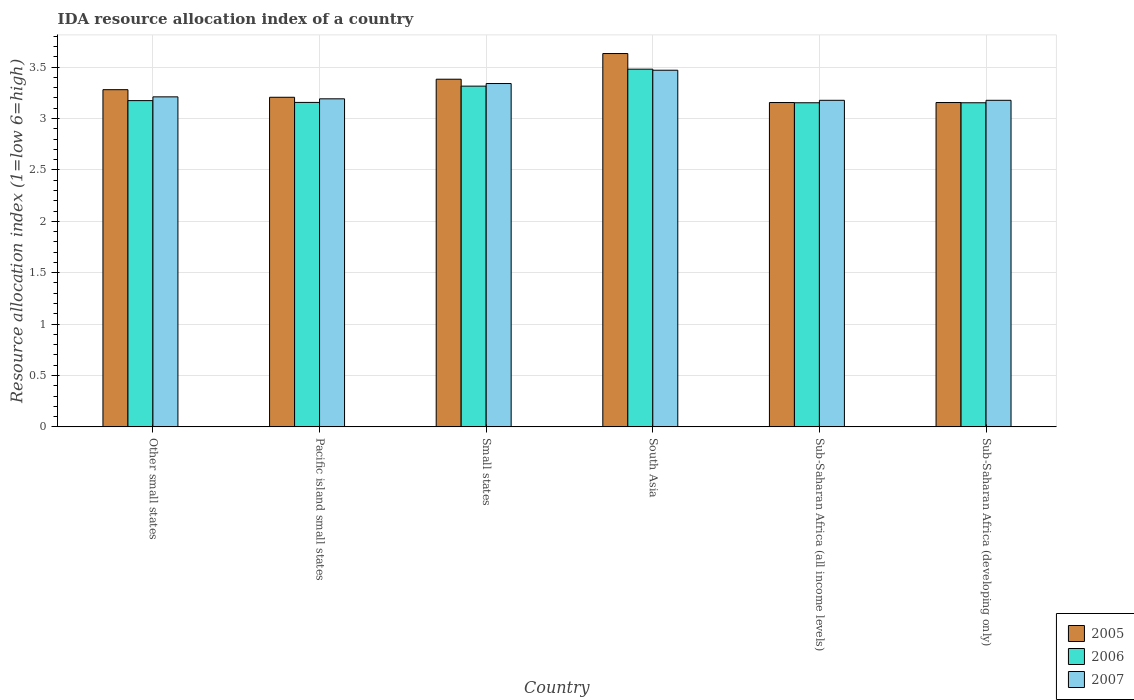In how many cases, is the number of bars for a given country not equal to the number of legend labels?
Offer a very short reply. 0. What is the IDA resource allocation index in 2005 in Pacific island small states?
Provide a succinct answer. 3.21. Across all countries, what is the maximum IDA resource allocation index in 2005?
Give a very brief answer. 3.63. Across all countries, what is the minimum IDA resource allocation index in 2007?
Give a very brief answer. 3.18. In which country was the IDA resource allocation index in 2006 maximum?
Give a very brief answer. South Asia. In which country was the IDA resource allocation index in 2007 minimum?
Offer a terse response. Sub-Saharan Africa (all income levels). What is the total IDA resource allocation index in 2006 in the graph?
Ensure brevity in your answer.  19.43. What is the difference between the IDA resource allocation index in 2006 in Small states and that in South Asia?
Your answer should be very brief. -0.17. What is the difference between the IDA resource allocation index in 2007 in Pacific island small states and the IDA resource allocation index in 2005 in South Asia?
Your answer should be very brief. -0.44. What is the average IDA resource allocation index in 2006 per country?
Provide a short and direct response. 3.24. What is the difference between the IDA resource allocation index of/in 2005 and IDA resource allocation index of/in 2007 in Small states?
Provide a short and direct response. 0.04. What is the ratio of the IDA resource allocation index in 2005 in Small states to that in Sub-Saharan Africa (all income levels)?
Give a very brief answer. 1.07. Is the difference between the IDA resource allocation index in 2005 in Small states and South Asia greater than the difference between the IDA resource allocation index in 2007 in Small states and South Asia?
Your response must be concise. No. What is the difference between the highest and the second highest IDA resource allocation index in 2005?
Make the answer very short. -0.25. What is the difference between the highest and the lowest IDA resource allocation index in 2007?
Offer a very short reply. 0.29. In how many countries, is the IDA resource allocation index in 2006 greater than the average IDA resource allocation index in 2006 taken over all countries?
Offer a terse response. 2. Is the sum of the IDA resource allocation index in 2007 in Small states and Sub-Saharan Africa (developing only) greater than the maximum IDA resource allocation index in 2005 across all countries?
Offer a terse response. Yes. What does the 1st bar from the left in Small states represents?
Your answer should be very brief. 2005. What does the 3rd bar from the right in Small states represents?
Make the answer very short. 2005. Is it the case that in every country, the sum of the IDA resource allocation index in 2006 and IDA resource allocation index in 2005 is greater than the IDA resource allocation index in 2007?
Offer a very short reply. Yes. How many bars are there?
Make the answer very short. 18. Are all the bars in the graph horizontal?
Make the answer very short. No. What is the difference between two consecutive major ticks on the Y-axis?
Give a very brief answer. 0.5. Does the graph contain grids?
Ensure brevity in your answer.  Yes. Where does the legend appear in the graph?
Make the answer very short. Bottom right. How are the legend labels stacked?
Ensure brevity in your answer.  Vertical. What is the title of the graph?
Offer a terse response. IDA resource allocation index of a country. What is the label or title of the Y-axis?
Make the answer very short. Resource allocation index (1=low 6=high). What is the Resource allocation index (1=low 6=high) in 2005 in Other small states?
Provide a short and direct response. 3.28. What is the Resource allocation index (1=low 6=high) in 2006 in Other small states?
Provide a succinct answer. 3.17. What is the Resource allocation index (1=low 6=high) of 2007 in Other small states?
Ensure brevity in your answer.  3.21. What is the Resource allocation index (1=low 6=high) of 2005 in Pacific island small states?
Your answer should be very brief. 3.21. What is the Resource allocation index (1=low 6=high) of 2006 in Pacific island small states?
Make the answer very short. 3.16. What is the Resource allocation index (1=low 6=high) in 2007 in Pacific island small states?
Keep it short and to the point. 3.19. What is the Resource allocation index (1=low 6=high) of 2005 in Small states?
Keep it short and to the point. 3.38. What is the Resource allocation index (1=low 6=high) of 2006 in Small states?
Ensure brevity in your answer.  3.31. What is the Resource allocation index (1=low 6=high) of 2007 in Small states?
Keep it short and to the point. 3.34. What is the Resource allocation index (1=low 6=high) of 2005 in South Asia?
Your answer should be compact. 3.63. What is the Resource allocation index (1=low 6=high) of 2006 in South Asia?
Your answer should be compact. 3.48. What is the Resource allocation index (1=low 6=high) in 2007 in South Asia?
Your response must be concise. 3.47. What is the Resource allocation index (1=low 6=high) of 2005 in Sub-Saharan Africa (all income levels)?
Provide a succinct answer. 3.16. What is the Resource allocation index (1=low 6=high) of 2006 in Sub-Saharan Africa (all income levels)?
Provide a succinct answer. 3.15. What is the Resource allocation index (1=low 6=high) of 2007 in Sub-Saharan Africa (all income levels)?
Offer a very short reply. 3.18. What is the Resource allocation index (1=low 6=high) of 2005 in Sub-Saharan Africa (developing only)?
Make the answer very short. 3.16. What is the Resource allocation index (1=low 6=high) of 2006 in Sub-Saharan Africa (developing only)?
Your answer should be compact. 3.15. What is the Resource allocation index (1=low 6=high) of 2007 in Sub-Saharan Africa (developing only)?
Your answer should be compact. 3.18. Across all countries, what is the maximum Resource allocation index (1=low 6=high) in 2005?
Offer a terse response. 3.63. Across all countries, what is the maximum Resource allocation index (1=low 6=high) of 2006?
Your response must be concise. 3.48. Across all countries, what is the maximum Resource allocation index (1=low 6=high) of 2007?
Keep it short and to the point. 3.47. Across all countries, what is the minimum Resource allocation index (1=low 6=high) in 2005?
Ensure brevity in your answer.  3.16. Across all countries, what is the minimum Resource allocation index (1=low 6=high) of 2006?
Provide a succinct answer. 3.15. Across all countries, what is the minimum Resource allocation index (1=low 6=high) in 2007?
Make the answer very short. 3.18. What is the total Resource allocation index (1=low 6=high) in 2005 in the graph?
Make the answer very short. 19.81. What is the total Resource allocation index (1=low 6=high) of 2006 in the graph?
Your answer should be compact. 19.43. What is the total Resource allocation index (1=low 6=high) in 2007 in the graph?
Make the answer very short. 19.57. What is the difference between the Resource allocation index (1=low 6=high) of 2005 in Other small states and that in Pacific island small states?
Your response must be concise. 0.07. What is the difference between the Resource allocation index (1=low 6=high) of 2006 in Other small states and that in Pacific island small states?
Your answer should be very brief. 0.02. What is the difference between the Resource allocation index (1=low 6=high) in 2007 in Other small states and that in Pacific island small states?
Give a very brief answer. 0.02. What is the difference between the Resource allocation index (1=low 6=high) in 2005 in Other small states and that in Small states?
Ensure brevity in your answer.  -0.1. What is the difference between the Resource allocation index (1=low 6=high) of 2006 in Other small states and that in Small states?
Your answer should be compact. -0.14. What is the difference between the Resource allocation index (1=low 6=high) of 2007 in Other small states and that in Small states?
Provide a short and direct response. -0.13. What is the difference between the Resource allocation index (1=low 6=high) of 2005 in Other small states and that in South Asia?
Offer a very short reply. -0.35. What is the difference between the Resource allocation index (1=low 6=high) of 2006 in Other small states and that in South Asia?
Provide a succinct answer. -0.31. What is the difference between the Resource allocation index (1=low 6=high) of 2007 in Other small states and that in South Asia?
Give a very brief answer. -0.26. What is the difference between the Resource allocation index (1=low 6=high) in 2005 in Other small states and that in Sub-Saharan Africa (all income levels)?
Your answer should be very brief. 0.12. What is the difference between the Resource allocation index (1=low 6=high) in 2006 in Other small states and that in Sub-Saharan Africa (all income levels)?
Make the answer very short. 0.02. What is the difference between the Resource allocation index (1=low 6=high) of 2007 in Other small states and that in Sub-Saharan Africa (all income levels)?
Provide a short and direct response. 0.03. What is the difference between the Resource allocation index (1=low 6=high) in 2005 in Other small states and that in Sub-Saharan Africa (developing only)?
Your answer should be very brief. 0.12. What is the difference between the Resource allocation index (1=low 6=high) in 2006 in Other small states and that in Sub-Saharan Africa (developing only)?
Give a very brief answer. 0.02. What is the difference between the Resource allocation index (1=low 6=high) of 2007 in Other small states and that in Sub-Saharan Africa (developing only)?
Your answer should be compact. 0.03. What is the difference between the Resource allocation index (1=low 6=high) in 2005 in Pacific island small states and that in Small states?
Make the answer very short. -0.18. What is the difference between the Resource allocation index (1=low 6=high) in 2006 in Pacific island small states and that in Small states?
Offer a very short reply. -0.16. What is the difference between the Resource allocation index (1=low 6=high) of 2007 in Pacific island small states and that in Small states?
Your answer should be compact. -0.15. What is the difference between the Resource allocation index (1=low 6=high) in 2005 in Pacific island small states and that in South Asia?
Give a very brief answer. -0.43. What is the difference between the Resource allocation index (1=low 6=high) in 2006 in Pacific island small states and that in South Asia?
Provide a succinct answer. -0.32. What is the difference between the Resource allocation index (1=low 6=high) of 2007 in Pacific island small states and that in South Asia?
Provide a short and direct response. -0.28. What is the difference between the Resource allocation index (1=low 6=high) of 2005 in Pacific island small states and that in Sub-Saharan Africa (all income levels)?
Keep it short and to the point. 0.05. What is the difference between the Resource allocation index (1=low 6=high) in 2006 in Pacific island small states and that in Sub-Saharan Africa (all income levels)?
Ensure brevity in your answer.  0. What is the difference between the Resource allocation index (1=low 6=high) of 2007 in Pacific island small states and that in Sub-Saharan Africa (all income levels)?
Give a very brief answer. 0.01. What is the difference between the Resource allocation index (1=low 6=high) of 2005 in Pacific island small states and that in Sub-Saharan Africa (developing only)?
Your answer should be compact. 0.05. What is the difference between the Resource allocation index (1=low 6=high) of 2006 in Pacific island small states and that in Sub-Saharan Africa (developing only)?
Keep it short and to the point. 0. What is the difference between the Resource allocation index (1=low 6=high) of 2007 in Pacific island small states and that in Sub-Saharan Africa (developing only)?
Offer a terse response. 0.01. What is the difference between the Resource allocation index (1=low 6=high) of 2005 in Small states and that in South Asia?
Make the answer very short. -0.25. What is the difference between the Resource allocation index (1=low 6=high) in 2006 in Small states and that in South Asia?
Your answer should be very brief. -0.17. What is the difference between the Resource allocation index (1=low 6=high) of 2007 in Small states and that in South Asia?
Make the answer very short. -0.13. What is the difference between the Resource allocation index (1=low 6=high) of 2005 in Small states and that in Sub-Saharan Africa (all income levels)?
Provide a succinct answer. 0.23. What is the difference between the Resource allocation index (1=low 6=high) in 2006 in Small states and that in Sub-Saharan Africa (all income levels)?
Provide a short and direct response. 0.16. What is the difference between the Resource allocation index (1=low 6=high) of 2007 in Small states and that in Sub-Saharan Africa (all income levels)?
Your answer should be very brief. 0.16. What is the difference between the Resource allocation index (1=low 6=high) of 2005 in Small states and that in Sub-Saharan Africa (developing only)?
Offer a very short reply. 0.23. What is the difference between the Resource allocation index (1=low 6=high) of 2006 in Small states and that in Sub-Saharan Africa (developing only)?
Provide a short and direct response. 0.16. What is the difference between the Resource allocation index (1=low 6=high) in 2007 in Small states and that in Sub-Saharan Africa (developing only)?
Give a very brief answer. 0.16. What is the difference between the Resource allocation index (1=low 6=high) of 2005 in South Asia and that in Sub-Saharan Africa (all income levels)?
Make the answer very short. 0.48. What is the difference between the Resource allocation index (1=low 6=high) in 2006 in South Asia and that in Sub-Saharan Africa (all income levels)?
Provide a short and direct response. 0.33. What is the difference between the Resource allocation index (1=low 6=high) in 2007 in South Asia and that in Sub-Saharan Africa (all income levels)?
Offer a very short reply. 0.29. What is the difference between the Resource allocation index (1=low 6=high) of 2005 in South Asia and that in Sub-Saharan Africa (developing only)?
Your answer should be compact. 0.48. What is the difference between the Resource allocation index (1=low 6=high) of 2006 in South Asia and that in Sub-Saharan Africa (developing only)?
Your answer should be very brief. 0.33. What is the difference between the Resource allocation index (1=low 6=high) of 2007 in South Asia and that in Sub-Saharan Africa (developing only)?
Ensure brevity in your answer.  0.29. What is the difference between the Resource allocation index (1=low 6=high) of 2005 in Sub-Saharan Africa (all income levels) and that in Sub-Saharan Africa (developing only)?
Provide a succinct answer. 0. What is the difference between the Resource allocation index (1=low 6=high) in 2006 in Sub-Saharan Africa (all income levels) and that in Sub-Saharan Africa (developing only)?
Your response must be concise. 0. What is the difference between the Resource allocation index (1=low 6=high) in 2005 in Other small states and the Resource allocation index (1=low 6=high) in 2006 in Pacific island small states?
Ensure brevity in your answer.  0.12. What is the difference between the Resource allocation index (1=low 6=high) in 2005 in Other small states and the Resource allocation index (1=low 6=high) in 2007 in Pacific island small states?
Ensure brevity in your answer.  0.09. What is the difference between the Resource allocation index (1=low 6=high) in 2006 in Other small states and the Resource allocation index (1=low 6=high) in 2007 in Pacific island small states?
Your answer should be compact. -0.02. What is the difference between the Resource allocation index (1=low 6=high) in 2005 in Other small states and the Resource allocation index (1=low 6=high) in 2006 in Small states?
Ensure brevity in your answer.  -0.03. What is the difference between the Resource allocation index (1=low 6=high) of 2005 in Other small states and the Resource allocation index (1=low 6=high) of 2007 in Small states?
Provide a succinct answer. -0.06. What is the difference between the Resource allocation index (1=low 6=high) in 2006 in Other small states and the Resource allocation index (1=low 6=high) in 2007 in Small states?
Ensure brevity in your answer.  -0.17. What is the difference between the Resource allocation index (1=low 6=high) in 2005 in Other small states and the Resource allocation index (1=low 6=high) in 2006 in South Asia?
Your answer should be compact. -0.2. What is the difference between the Resource allocation index (1=low 6=high) of 2005 in Other small states and the Resource allocation index (1=low 6=high) of 2007 in South Asia?
Offer a very short reply. -0.19. What is the difference between the Resource allocation index (1=low 6=high) in 2006 in Other small states and the Resource allocation index (1=low 6=high) in 2007 in South Asia?
Make the answer very short. -0.3. What is the difference between the Resource allocation index (1=low 6=high) in 2005 in Other small states and the Resource allocation index (1=low 6=high) in 2006 in Sub-Saharan Africa (all income levels)?
Offer a terse response. 0.13. What is the difference between the Resource allocation index (1=low 6=high) of 2005 in Other small states and the Resource allocation index (1=low 6=high) of 2007 in Sub-Saharan Africa (all income levels)?
Make the answer very short. 0.1. What is the difference between the Resource allocation index (1=low 6=high) of 2006 in Other small states and the Resource allocation index (1=low 6=high) of 2007 in Sub-Saharan Africa (all income levels)?
Your answer should be very brief. -0. What is the difference between the Resource allocation index (1=low 6=high) of 2005 in Other small states and the Resource allocation index (1=low 6=high) of 2006 in Sub-Saharan Africa (developing only)?
Your response must be concise. 0.13. What is the difference between the Resource allocation index (1=low 6=high) of 2005 in Other small states and the Resource allocation index (1=low 6=high) of 2007 in Sub-Saharan Africa (developing only)?
Offer a terse response. 0.1. What is the difference between the Resource allocation index (1=low 6=high) of 2006 in Other small states and the Resource allocation index (1=low 6=high) of 2007 in Sub-Saharan Africa (developing only)?
Offer a very short reply. -0. What is the difference between the Resource allocation index (1=low 6=high) in 2005 in Pacific island small states and the Resource allocation index (1=low 6=high) in 2006 in Small states?
Provide a succinct answer. -0.11. What is the difference between the Resource allocation index (1=low 6=high) of 2005 in Pacific island small states and the Resource allocation index (1=low 6=high) of 2007 in Small states?
Provide a succinct answer. -0.13. What is the difference between the Resource allocation index (1=low 6=high) of 2006 in Pacific island small states and the Resource allocation index (1=low 6=high) of 2007 in Small states?
Keep it short and to the point. -0.18. What is the difference between the Resource allocation index (1=low 6=high) of 2005 in Pacific island small states and the Resource allocation index (1=low 6=high) of 2006 in South Asia?
Your answer should be compact. -0.27. What is the difference between the Resource allocation index (1=low 6=high) in 2005 in Pacific island small states and the Resource allocation index (1=low 6=high) in 2007 in South Asia?
Provide a succinct answer. -0.26. What is the difference between the Resource allocation index (1=low 6=high) in 2006 in Pacific island small states and the Resource allocation index (1=low 6=high) in 2007 in South Asia?
Offer a very short reply. -0.31. What is the difference between the Resource allocation index (1=low 6=high) in 2005 in Pacific island small states and the Resource allocation index (1=low 6=high) in 2006 in Sub-Saharan Africa (all income levels)?
Your response must be concise. 0.05. What is the difference between the Resource allocation index (1=low 6=high) of 2005 in Pacific island small states and the Resource allocation index (1=low 6=high) of 2007 in Sub-Saharan Africa (all income levels)?
Your answer should be very brief. 0.03. What is the difference between the Resource allocation index (1=low 6=high) in 2006 in Pacific island small states and the Resource allocation index (1=low 6=high) in 2007 in Sub-Saharan Africa (all income levels)?
Ensure brevity in your answer.  -0.02. What is the difference between the Resource allocation index (1=low 6=high) of 2005 in Pacific island small states and the Resource allocation index (1=low 6=high) of 2006 in Sub-Saharan Africa (developing only)?
Make the answer very short. 0.05. What is the difference between the Resource allocation index (1=low 6=high) of 2005 in Pacific island small states and the Resource allocation index (1=low 6=high) of 2007 in Sub-Saharan Africa (developing only)?
Your answer should be compact. 0.03. What is the difference between the Resource allocation index (1=low 6=high) in 2006 in Pacific island small states and the Resource allocation index (1=low 6=high) in 2007 in Sub-Saharan Africa (developing only)?
Your answer should be very brief. -0.02. What is the difference between the Resource allocation index (1=low 6=high) of 2005 in Small states and the Resource allocation index (1=low 6=high) of 2006 in South Asia?
Keep it short and to the point. -0.1. What is the difference between the Resource allocation index (1=low 6=high) in 2005 in Small states and the Resource allocation index (1=low 6=high) in 2007 in South Asia?
Give a very brief answer. -0.09. What is the difference between the Resource allocation index (1=low 6=high) of 2006 in Small states and the Resource allocation index (1=low 6=high) of 2007 in South Asia?
Your answer should be very brief. -0.15. What is the difference between the Resource allocation index (1=low 6=high) of 2005 in Small states and the Resource allocation index (1=low 6=high) of 2006 in Sub-Saharan Africa (all income levels)?
Offer a terse response. 0.23. What is the difference between the Resource allocation index (1=low 6=high) in 2005 in Small states and the Resource allocation index (1=low 6=high) in 2007 in Sub-Saharan Africa (all income levels)?
Your answer should be very brief. 0.21. What is the difference between the Resource allocation index (1=low 6=high) in 2006 in Small states and the Resource allocation index (1=low 6=high) in 2007 in Sub-Saharan Africa (all income levels)?
Your response must be concise. 0.14. What is the difference between the Resource allocation index (1=low 6=high) of 2005 in Small states and the Resource allocation index (1=low 6=high) of 2006 in Sub-Saharan Africa (developing only)?
Offer a terse response. 0.23. What is the difference between the Resource allocation index (1=low 6=high) in 2005 in Small states and the Resource allocation index (1=low 6=high) in 2007 in Sub-Saharan Africa (developing only)?
Ensure brevity in your answer.  0.21. What is the difference between the Resource allocation index (1=low 6=high) in 2006 in Small states and the Resource allocation index (1=low 6=high) in 2007 in Sub-Saharan Africa (developing only)?
Keep it short and to the point. 0.14. What is the difference between the Resource allocation index (1=low 6=high) in 2005 in South Asia and the Resource allocation index (1=low 6=high) in 2006 in Sub-Saharan Africa (all income levels)?
Make the answer very short. 0.48. What is the difference between the Resource allocation index (1=low 6=high) of 2005 in South Asia and the Resource allocation index (1=low 6=high) of 2007 in Sub-Saharan Africa (all income levels)?
Your answer should be very brief. 0.45. What is the difference between the Resource allocation index (1=low 6=high) of 2006 in South Asia and the Resource allocation index (1=low 6=high) of 2007 in Sub-Saharan Africa (all income levels)?
Your response must be concise. 0.3. What is the difference between the Resource allocation index (1=low 6=high) of 2005 in South Asia and the Resource allocation index (1=low 6=high) of 2006 in Sub-Saharan Africa (developing only)?
Offer a terse response. 0.48. What is the difference between the Resource allocation index (1=low 6=high) in 2005 in South Asia and the Resource allocation index (1=low 6=high) in 2007 in Sub-Saharan Africa (developing only)?
Your answer should be compact. 0.45. What is the difference between the Resource allocation index (1=low 6=high) in 2006 in South Asia and the Resource allocation index (1=low 6=high) in 2007 in Sub-Saharan Africa (developing only)?
Your answer should be very brief. 0.3. What is the difference between the Resource allocation index (1=low 6=high) in 2005 in Sub-Saharan Africa (all income levels) and the Resource allocation index (1=low 6=high) in 2006 in Sub-Saharan Africa (developing only)?
Offer a terse response. 0. What is the difference between the Resource allocation index (1=low 6=high) in 2005 in Sub-Saharan Africa (all income levels) and the Resource allocation index (1=low 6=high) in 2007 in Sub-Saharan Africa (developing only)?
Provide a short and direct response. -0.02. What is the difference between the Resource allocation index (1=low 6=high) in 2006 in Sub-Saharan Africa (all income levels) and the Resource allocation index (1=low 6=high) in 2007 in Sub-Saharan Africa (developing only)?
Offer a very short reply. -0.02. What is the average Resource allocation index (1=low 6=high) in 2005 per country?
Give a very brief answer. 3.3. What is the average Resource allocation index (1=low 6=high) in 2006 per country?
Your answer should be very brief. 3.24. What is the average Resource allocation index (1=low 6=high) in 2007 per country?
Offer a terse response. 3.26. What is the difference between the Resource allocation index (1=low 6=high) of 2005 and Resource allocation index (1=low 6=high) of 2006 in Other small states?
Keep it short and to the point. 0.11. What is the difference between the Resource allocation index (1=low 6=high) in 2005 and Resource allocation index (1=low 6=high) in 2007 in Other small states?
Offer a terse response. 0.07. What is the difference between the Resource allocation index (1=low 6=high) of 2006 and Resource allocation index (1=low 6=high) of 2007 in Other small states?
Provide a succinct answer. -0.04. What is the difference between the Resource allocation index (1=low 6=high) in 2005 and Resource allocation index (1=low 6=high) in 2006 in Pacific island small states?
Provide a short and direct response. 0.05. What is the difference between the Resource allocation index (1=low 6=high) in 2005 and Resource allocation index (1=low 6=high) in 2007 in Pacific island small states?
Keep it short and to the point. 0.01. What is the difference between the Resource allocation index (1=low 6=high) in 2006 and Resource allocation index (1=low 6=high) in 2007 in Pacific island small states?
Offer a terse response. -0.04. What is the difference between the Resource allocation index (1=low 6=high) in 2005 and Resource allocation index (1=low 6=high) in 2006 in Small states?
Offer a very short reply. 0.07. What is the difference between the Resource allocation index (1=low 6=high) in 2005 and Resource allocation index (1=low 6=high) in 2007 in Small states?
Offer a terse response. 0.04. What is the difference between the Resource allocation index (1=low 6=high) of 2006 and Resource allocation index (1=low 6=high) of 2007 in Small states?
Make the answer very short. -0.03. What is the difference between the Resource allocation index (1=low 6=high) of 2005 and Resource allocation index (1=low 6=high) of 2006 in South Asia?
Provide a short and direct response. 0.15. What is the difference between the Resource allocation index (1=low 6=high) in 2005 and Resource allocation index (1=low 6=high) in 2007 in South Asia?
Your answer should be very brief. 0.16. What is the difference between the Resource allocation index (1=low 6=high) in 2006 and Resource allocation index (1=low 6=high) in 2007 in South Asia?
Provide a short and direct response. 0.01. What is the difference between the Resource allocation index (1=low 6=high) in 2005 and Resource allocation index (1=low 6=high) in 2006 in Sub-Saharan Africa (all income levels)?
Keep it short and to the point. 0. What is the difference between the Resource allocation index (1=low 6=high) of 2005 and Resource allocation index (1=low 6=high) of 2007 in Sub-Saharan Africa (all income levels)?
Offer a very short reply. -0.02. What is the difference between the Resource allocation index (1=low 6=high) in 2006 and Resource allocation index (1=low 6=high) in 2007 in Sub-Saharan Africa (all income levels)?
Give a very brief answer. -0.02. What is the difference between the Resource allocation index (1=low 6=high) of 2005 and Resource allocation index (1=low 6=high) of 2006 in Sub-Saharan Africa (developing only)?
Your answer should be very brief. 0. What is the difference between the Resource allocation index (1=low 6=high) of 2005 and Resource allocation index (1=low 6=high) of 2007 in Sub-Saharan Africa (developing only)?
Your answer should be compact. -0.02. What is the difference between the Resource allocation index (1=low 6=high) of 2006 and Resource allocation index (1=low 6=high) of 2007 in Sub-Saharan Africa (developing only)?
Offer a terse response. -0.02. What is the ratio of the Resource allocation index (1=low 6=high) of 2006 in Other small states to that in Pacific island small states?
Make the answer very short. 1.01. What is the ratio of the Resource allocation index (1=low 6=high) in 2005 in Other small states to that in Small states?
Ensure brevity in your answer.  0.97. What is the ratio of the Resource allocation index (1=low 6=high) in 2006 in Other small states to that in Small states?
Offer a terse response. 0.96. What is the ratio of the Resource allocation index (1=low 6=high) in 2007 in Other small states to that in Small states?
Offer a terse response. 0.96. What is the ratio of the Resource allocation index (1=low 6=high) of 2005 in Other small states to that in South Asia?
Keep it short and to the point. 0.9. What is the ratio of the Resource allocation index (1=low 6=high) of 2006 in Other small states to that in South Asia?
Offer a very short reply. 0.91. What is the ratio of the Resource allocation index (1=low 6=high) of 2007 in Other small states to that in South Asia?
Ensure brevity in your answer.  0.93. What is the ratio of the Resource allocation index (1=low 6=high) of 2005 in Other small states to that in Sub-Saharan Africa (all income levels)?
Ensure brevity in your answer.  1.04. What is the ratio of the Resource allocation index (1=low 6=high) in 2006 in Other small states to that in Sub-Saharan Africa (all income levels)?
Provide a succinct answer. 1.01. What is the ratio of the Resource allocation index (1=low 6=high) of 2007 in Other small states to that in Sub-Saharan Africa (all income levels)?
Give a very brief answer. 1.01. What is the ratio of the Resource allocation index (1=low 6=high) in 2005 in Other small states to that in Sub-Saharan Africa (developing only)?
Offer a terse response. 1.04. What is the ratio of the Resource allocation index (1=low 6=high) of 2006 in Other small states to that in Sub-Saharan Africa (developing only)?
Offer a terse response. 1.01. What is the ratio of the Resource allocation index (1=low 6=high) in 2007 in Other small states to that in Sub-Saharan Africa (developing only)?
Your answer should be very brief. 1.01. What is the ratio of the Resource allocation index (1=low 6=high) in 2005 in Pacific island small states to that in Small states?
Keep it short and to the point. 0.95. What is the ratio of the Resource allocation index (1=low 6=high) in 2006 in Pacific island small states to that in Small states?
Make the answer very short. 0.95. What is the ratio of the Resource allocation index (1=low 6=high) in 2007 in Pacific island small states to that in Small states?
Offer a terse response. 0.96. What is the ratio of the Resource allocation index (1=low 6=high) in 2005 in Pacific island small states to that in South Asia?
Keep it short and to the point. 0.88. What is the ratio of the Resource allocation index (1=low 6=high) of 2006 in Pacific island small states to that in South Asia?
Your answer should be very brief. 0.91. What is the ratio of the Resource allocation index (1=low 6=high) in 2007 in Pacific island small states to that in South Asia?
Keep it short and to the point. 0.92. What is the ratio of the Resource allocation index (1=low 6=high) in 2005 in Pacific island small states to that in Sub-Saharan Africa (all income levels)?
Your response must be concise. 1.02. What is the ratio of the Resource allocation index (1=low 6=high) of 2005 in Pacific island small states to that in Sub-Saharan Africa (developing only)?
Provide a succinct answer. 1.02. What is the ratio of the Resource allocation index (1=low 6=high) in 2006 in Pacific island small states to that in Sub-Saharan Africa (developing only)?
Your answer should be very brief. 1. What is the ratio of the Resource allocation index (1=low 6=high) in 2007 in Pacific island small states to that in Sub-Saharan Africa (developing only)?
Your answer should be very brief. 1. What is the ratio of the Resource allocation index (1=low 6=high) of 2005 in Small states to that in South Asia?
Ensure brevity in your answer.  0.93. What is the ratio of the Resource allocation index (1=low 6=high) in 2006 in Small states to that in South Asia?
Keep it short and to the point. 0.95. What is the ratio of the Resource allocation index (1=low 6=high) in 2007 in Small states to that in South Asia?
Your answer should be compact. 0.96. What is the ratio of the Resource allocation index (1=low 6=high) of 2005 in Small states to that in Sub-Saharan Africa (all income levels)?
Make the answer very short. 1.07. What is the ratio of the Resource allocation index (1=low 6=high) of 2006 in Small states to that in Sub-Saharan Africa (all income levels)?
Your answer should be compact. 1.05. What is the ratio of the Resource allocation index (1=low 6=high) of 2007 in Small states to that in Sub-Saharan Africa (all income levels)?
Ensure brevity in your answer.  1.05. What is the ratio of the Resource allocation index (1=low 6=high) of 2005 in Small states to that in Sub-Saharan Africa (developing only)?
Make the answer very short. 1.07. What is the ratio of the Resource allocation index (1=low 6=high) of 2006 in Small states to that in Sub-Saharan Africa (developing only)?
Keep it short and to the point. 1.05. What is the ratio of the Resource allocation index (1=low 6=high) in 2007 in Small states to that in Sub-Saharan Africa (developing only)?
Keep it short and to the point. 1.05. What is the ratio of the Resource allocation index (1=low 6=high) in 2005 in South Asia to that in Sub-Saharan Africa (all income levels)?
Offer a very short reply. 1.15. What is the ratio of the Resource allocation index (1=low 6=high) in 2006 in South Asia to that in Sub-Saharan Africa (all income levels)?
Provide a succinct answer. 1.1. What is the ratio of the Resource allocation index (1=low 6=high) in 2007 in South Asia to that in Sub-Saharan Africa (all income levels)?
Keep it short and to the point. 1.09. What is the ratio of the Resource allocation index (1=low 6=high) in 2005 in South Asia to that in Sub-Saharan Africa (developing only)?
Give a very brief answer. 1.15. What is the ratio of the Resource allocation index (1=low 6=high) of 2006 in South Asia to that in Sub-Saharan Africa (developing only)?
Ensure brevity in your answer.  1.1. What is the ratio of the Resource allocation index (1=low 6=high) in 2007 in South Asia to that in Sub-Saharan Africa (developing only)?
Make the answer very short. 1.09. What is the ratio of the Resource allocation index (1=low 6=high) in 2005 in Sub-Saharan Africa (all income levels) to that in Sub-Saharan Africa (developing only)?
Give a very brief answer. 1. What is the ratio of the Resource allocation index (1=low 6=high) of 2006 in Sub-Saharan Africa (all income levels) to that in Sub-Saharan Africa (developing only)?
Provide a short and direct response. 1. What is the difference between the highest and the second highest Resource allocation index (1=low 6=high) in 2005?
Provide a succinct answer. 0.25. What is the difference between the highest and the second highest Resource allocation index (1=low 6=high) in 2006?
Your response must be concise. 0.17. What is the difference between the highest and the second highest Resource allocation index (1=low 6=high) of 2007?
Your response must be concise. 0.13. What is the difference between the highest and the lowest Resource allocation index (1=low 6=high) of 2005?
Your answer should be very brief. 0.48. What is the difference between the highest and the lowest Resource allocation index (1=low 6=high) of 2006?
Make the answer very short. 0.33. What is the difference between the highest and the lowest Resource allocation index (1=low 6=high) of 2007?
Provide a short and direct response. 0.29. 